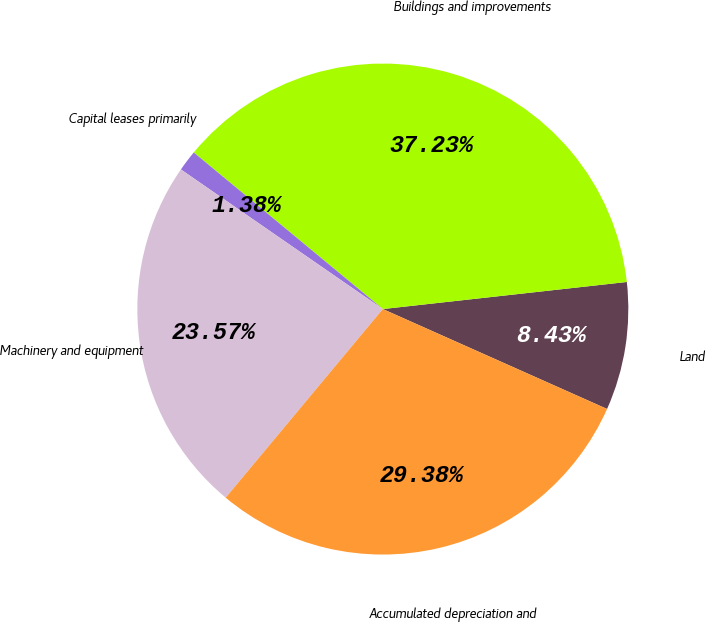Convert chart to OTSL. <chart><loc_0><loc_0><loc_500><loc_500><pie_chart><fcel>Land<fcel>Buildings and improvements<fcel>Capital leases primarily<fcel>Machinery and equipment<fcel>Accumulated depreciation and<nl><fcel>8.43%<fcel>37.23%<fcel>1.38%<fcel>23.57%<fcel>29.38%<nl></chart> 